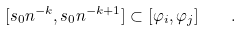Convert formula to latex. <formula><loc_0><loc_0><loc_500><loc_500>[ s _ { 0 } n ^ { - k } , s _ { 0 } n ^ { - k + 1 } ] \subset [ \varphi _ { i } , \varphi _ { j } ] \quad .</formula> 